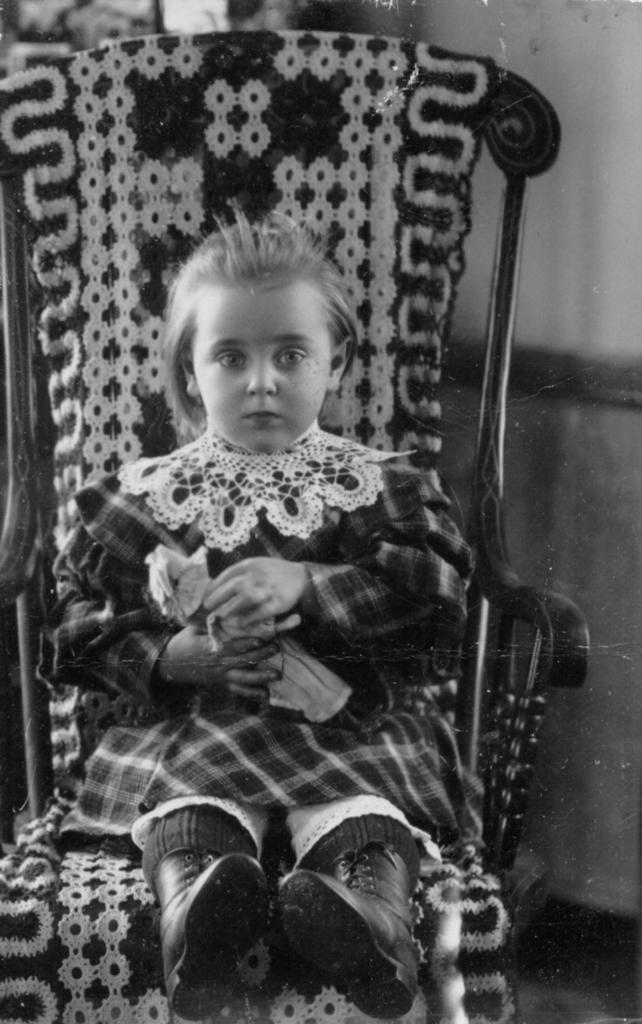Describe this image in one or two sentences. In this image, a girl is sat on the chair. She hold a toy in her hand. She wear a dress and boot. 